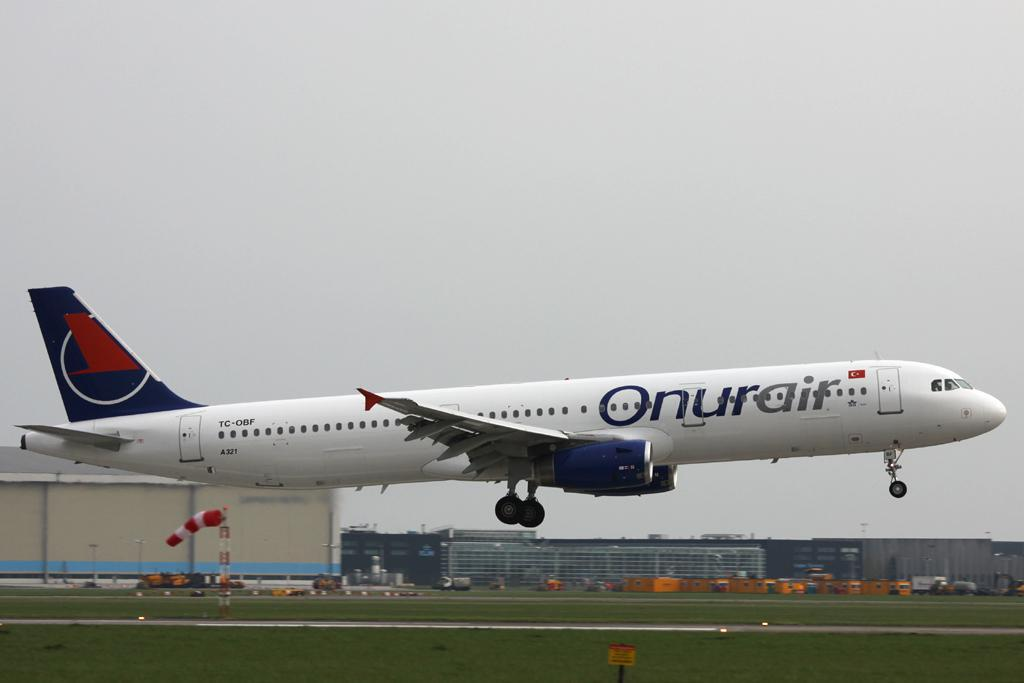<image>
Relay a brief, clear account of the picture shown. A large Onurair passenger jet almost landed at an airport 